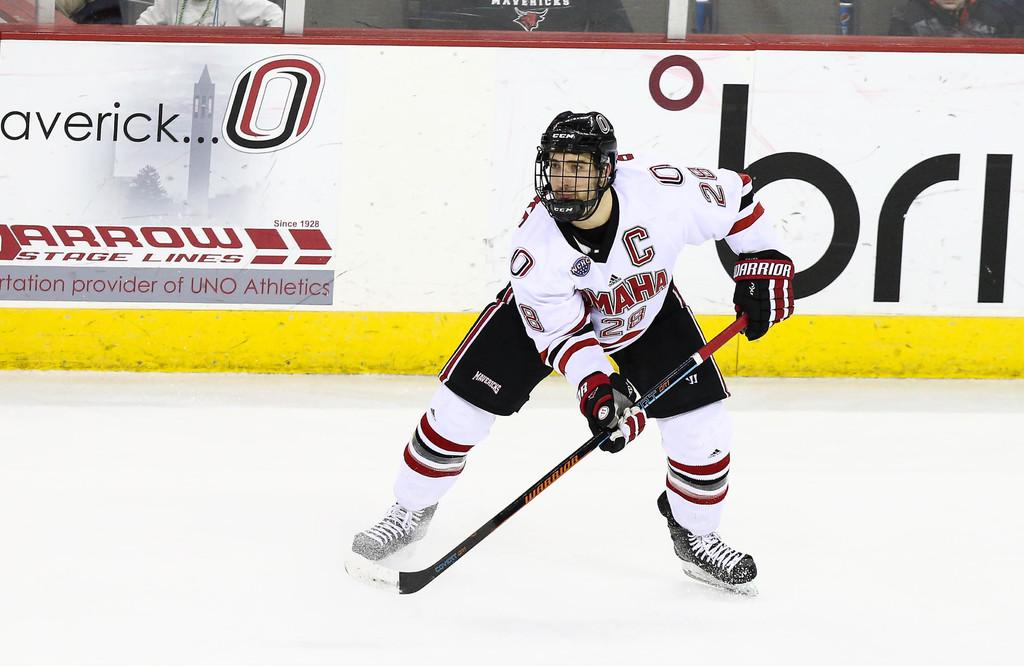Provide a one-sentence caption for the provided image. Player holding a hockey stick in front of a giant number 0. 